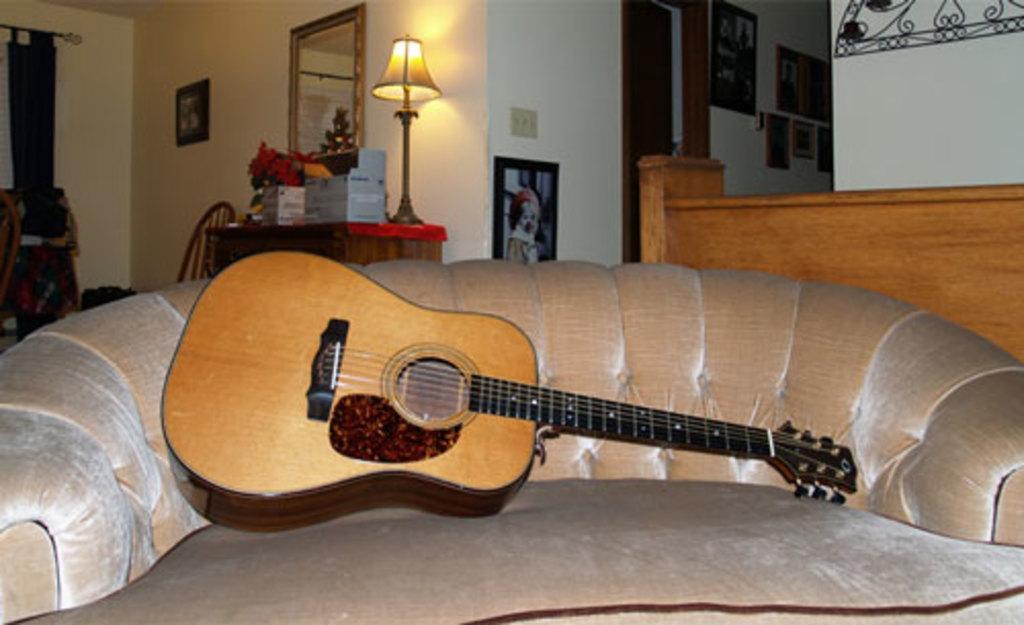How would you summarize this image in a sentence or two? This picture is taken in a room, In that there is a sofa in light yellow color and there is a music instruments placed on the sofa which is in dark yellow color and black color, In the right side there is a box in yellow color, in the left side there is a mirror is yellow color , There is a lamp, In the background there is a wall in white color,And there is a door in brown color. 